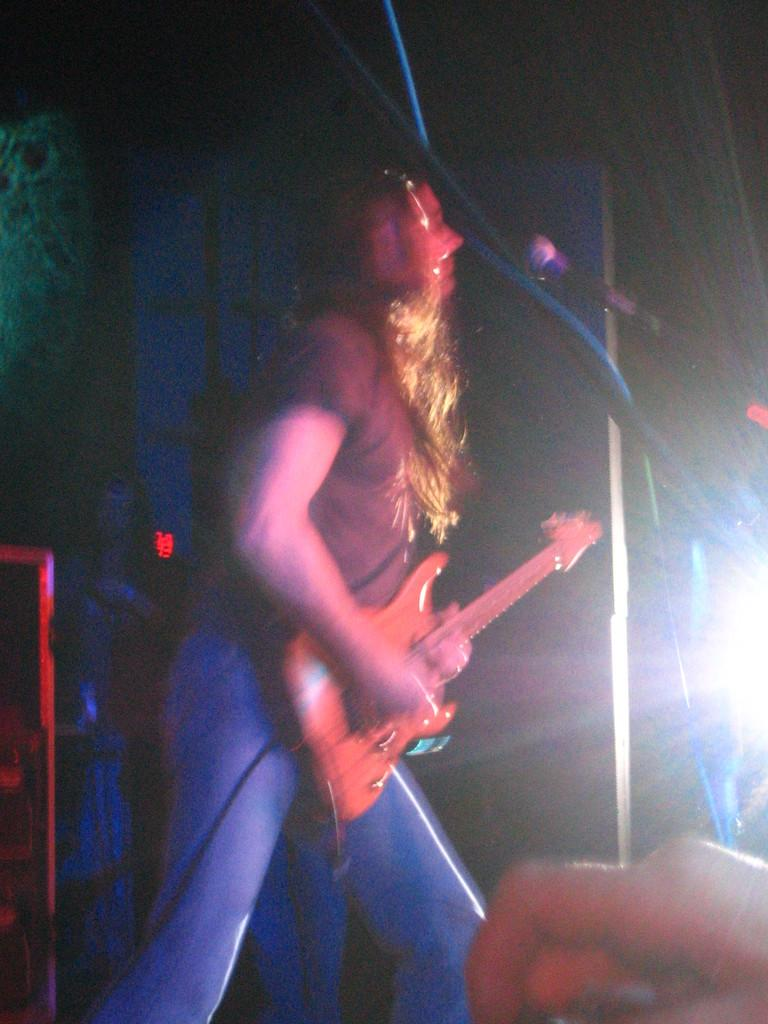Who is the main subject in the image? There is a woman in the image. What is the woman holding in the image? The woman is holding a guitar. What is the woman doing with the guitar? The woman is playing the guitar. What is in front of the woman that might be used for amplifying her voice? There is a microphone in front of the woman. What can be seen in the background of the image? There is a light in the background of the image. How does the woman wash her hands while playing the guitar in the image? There is no indication in the image that the woman is washing her hands or that there is a sink or water source nearby. 